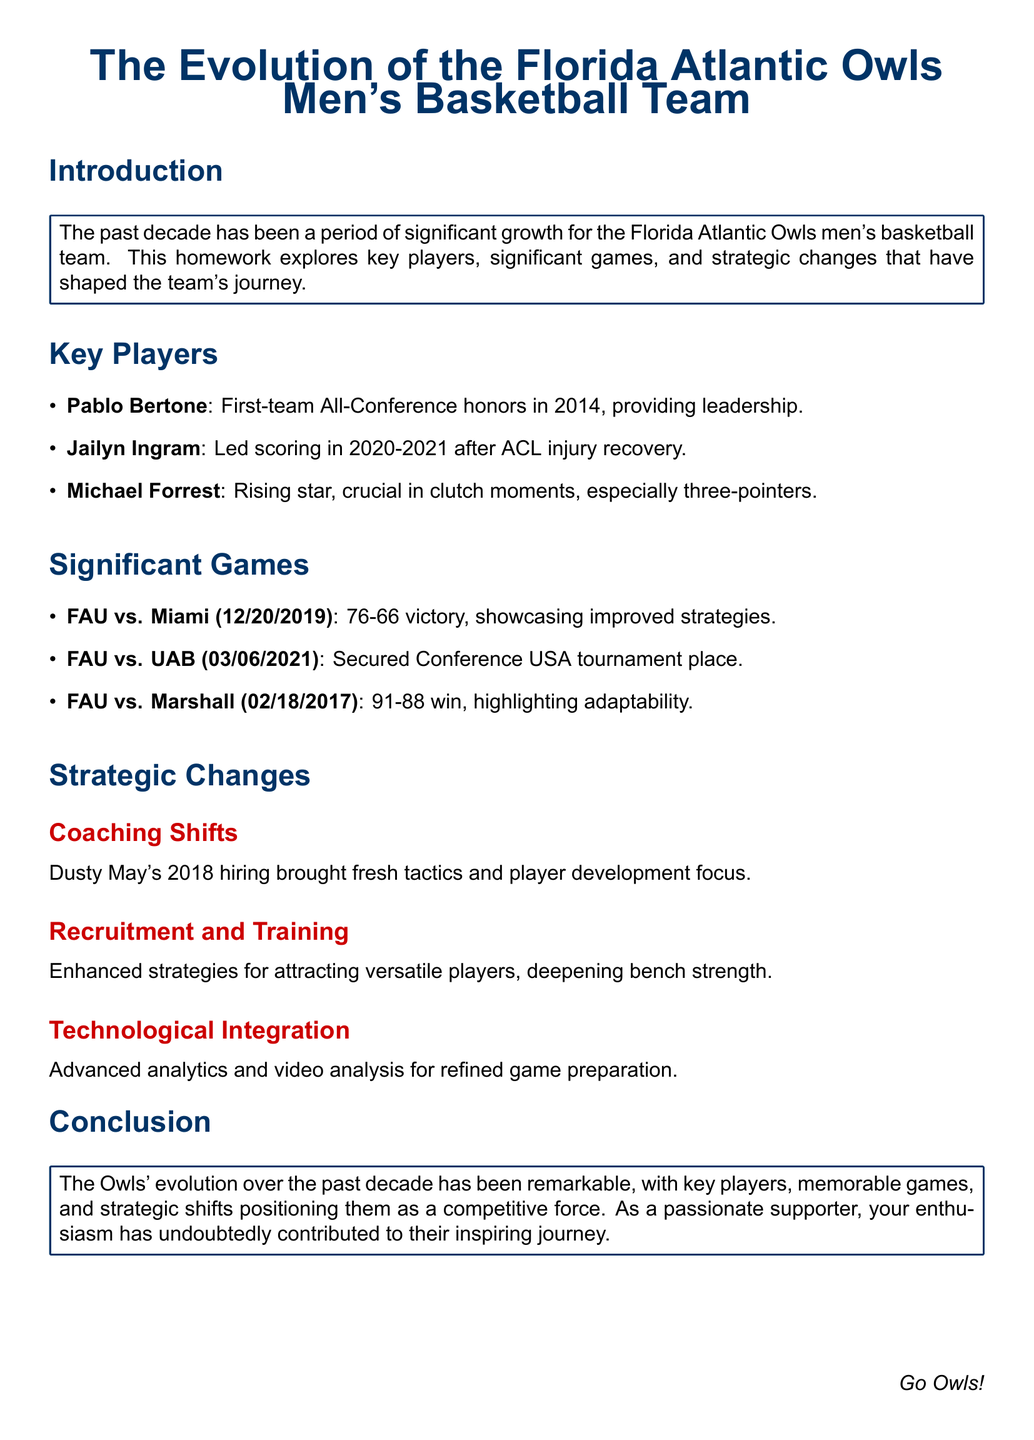What are the names of the key players highlighted in the document? The document lists key players including Pablo Bertone, Jailyn Ingram, and Michael Forrest.
Answer: Pablo Bertone, Jailyn Ingram, Michael Forrest What significant game did FAU win against Miami? The document mentions a noteworthy game where FAU defeated Miami with a score of 76-66.
Answer: 76-66 In what year did Dusty May become the head coach? The document states that Dusty May was hired in 2018.
Answer: 2018 Which player provided leadership in 2014? The document identifies Pablo Bertone as the player who provided leadership in 2014.
Answer: Pablo Bertone What type of strategies were enhanced for recruitment? The document notes enhanced strategies for attracting versatile players.
Answer: Versatile players What was the score in the FAU vs. Marshall game? The document indicates that FAU won against Marshall with a score of 91-88.
Answer: 91-88 What aspect of game preparation was improved with technology? The document mentions advanced analytics and video analysis as improvements for game preparation.
Answer: Advanced analytics and video analysis How many points did Jailyn Ingram lead in scoring during the 2020-2021 season? The document indicates that he led scoring after recovering from an ACL injury but does not specify a point total.
Answer: Not specified What is the focus of Dusty May's coaching tactics? The document highlights a focus on player development in Dusty May's coaching tactics.
Answer: Player development 